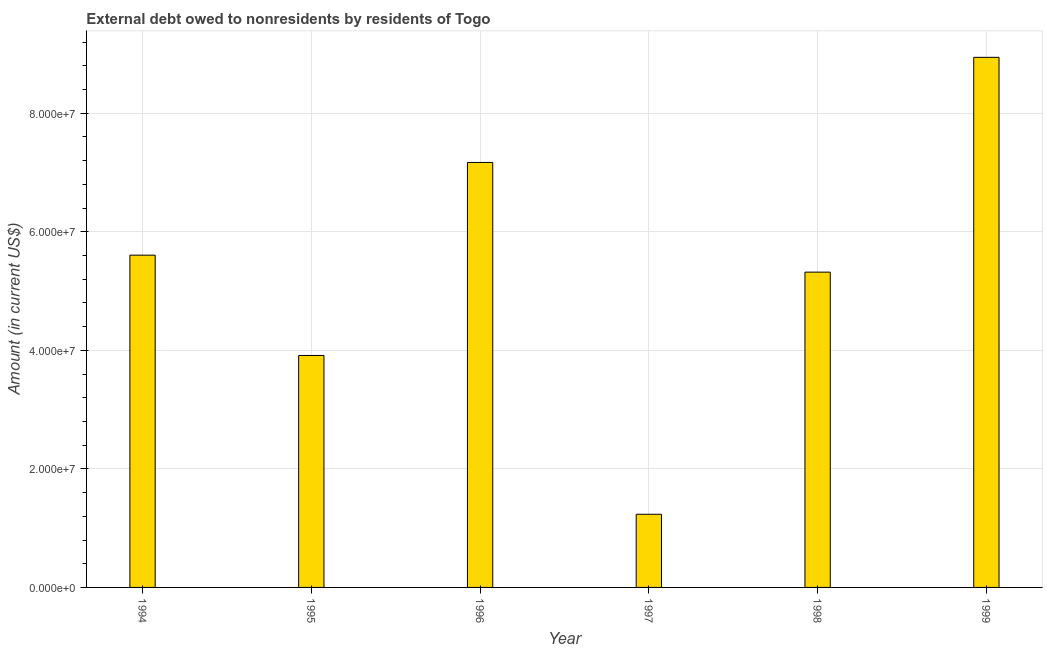What is the title of the graph?
Your answer should be very brief. External debt owed to nonresidents by residents of Togo. What is the label or title of the X-axis?
Make the answer very short. Year. What is the label or title of the Y-axis?
Provide a short and direct response. Amount (in current US$). What is the debt in 1994?
Offer a terse response. 5.61e+07. Across all years, what is the maximum debt?
Give a very brief answer. 8.94e+07. Across all years, what is the minimum debt?
Ensure brevity in your answer.  1.23e+07. What is the sum of the debt?
Offer a very short reply. 3.22e+08. What is the difference between the debt in 1995 and 1997?
Provide a short and direct response. 2.68e+07. What is the average debt per year?
Your answer should be very brief. 5.36e+07. What is the median debt?
Provide a short and direct response. 5.46e+07. Do a majority of the years between 1999 and 1995 (inclusive) have debt greater than 24000000 US$?
Keep it short and to the point. Yes. What is the ratio of the debt in 1997 to that in 1999?
Offer a very short reply. 0.14. Is the debt in 1996 less than that in 1998?
Your response must be concise. No. What is the difference between the highest and the second highest debt?
Offer a terse response. 1.77e+07. What is the difference between the highest and the lowest debt?
Give a very brief answer. 7.71e+07. In how many years, is the debt greater than the average debt taken over all years?
Offer a very short reply. 3. Are all the bars in the graph horizontal?
Keep it short and to the point. No. What is the difference between two consecutive major ticks on the Y-axis?
Provide a succinct answer. 2.00e+07. Are the values on the major ticks of Y-axis written in scientific E-notation?
Provide a succinct answer. Yes. What is the Amount (in current US$) in 1994?
Keep it short and to the point. 5.61e+07. What is the Amount (in current US$) of 1995?
Your response must be concise. 3.91e+07. What is the Amount (in current US$) of 1996?
Offer a very short reply. 7.17e+07. What is the Amount (in current US$) of 1997?
Your answer should be very brief. 1.23e+07. What is the Amount (in current US$) in 1998?
Your answer should be very brief. 5.32e+07. What is the Amount (in current US$) in 1999?
Offer a very short reply. 8.94e+07. What is the difference between the Amount (in current US$) in 1994 and 1995?
Your answer should be very brief. 1.69e+07. What is the difference between the Amount (in current US$) in 1994 and 1996?
Your response must be concise. -1.56e+07. What is the difference between the Amount (in current US$) in 1994 and 1997?
Ensure brevity in your answer.  4.37e+07. What is the difference between the Amount (in current US$) in 1994 and 1998?
Provide a succinct answer. 2.86e+06. What is the difference between the Amount (in current US$) in 1994 and 1999?
Make the answer very short. -3.34e+07. What is the difference between the Amount (in current US$) in 1995 and 1996?
Give a very brief answer. -3.26e+07. What is the difference between the Amount (in current US$) in 1995 and 1997?
Your answer should be very brief. 2.68e+07. What is the difference between the Amount (in current US$) in 1995 and 1998?
Offer a very short reply. -1.41e+07. What is the difference between the Amount (in current US$) in 1995 and 1999?
Ensure brevity in your answer.  -5.03e+07. What is the difference between the Amount (in current US$) in 1996 and 1997?
Your answer should be very brief. 5.94e+07. What is the difference between the Amount (in current US$) in 1996 and 1998?
Give a very brief answer. 1.85e+07. What is the difference between the Amount (in current US$) in 1996 and 1999?
Your answer should be compact. -1.77e+07. What is the difference between the Amount (in current US$) in 1997 and 1998?
Your response must be concise. -4.09e+07. What is the difference between the Amount (in current US$) in 1997 and 1999?
Keep it short and to the point. -7.71e+07. What is the difference between the Amount (in current US$) in 1998 and 1999?
Your response must be concise. -3.62e+07. What is the ratio of the Amount (in current US$) in 1994 to that in 1995?
Your response must be concise. 1.43. What is the ratio of the Amount (in current US$) in 1994 to that in 1996?
Provide a succinct answer. 0.78. What is the ratio of the Amount (in current US$) in 1994 to that in 1997?
Your response must be concise. 4.54. What is the ratio of the Amount (in current US$) in 1994 to that in 1998?
Offer a terse response. 1.05. What is the ratio of the Amount (in current US$) in 1994 to that in 1999?
Ensure brevity in your answer.  0.63. What is the ratio of the Amount (in current US$) in 1995 to that in 1996?
Provide a short and direct response. 0.55. What is the ratio of the Amount (in current US$) in 1995 to that in 1997?
Your answer should be compact. 3.17. What is the ratio of the Amount (in current US$) in 1995 to that in 1998?
Your response must be concise. 0.74. What is the ratio of the Amount (in current US$) in 1995 to that in 1999?
Make the answer very short. 0.44. What is the ratio of the Amount (in current US$) in 1996 to that in 1997?
Your answer should be compact. 5.81. What is the ratio of the Amount (in current US$) in 1996 to that in 1998?
Your answer should be compact. 1.35. What is the ratio of the Amount (in current US$) in 1996 to that in 1999?
Give a very brief answer. 0.8. What is the ratio of the Amount (in current US$) in 1997 to that in 1998?
Ensure brevity in your answer.  0.23. What is the ratio of the Amount (in current US$) in 1997 to that in 1999?
Give a very brief answer. 0.14. What is the ratio of the Amount (in current US$) in 1998 to that in 1999?
Provide a short and direct response. 0.59. 